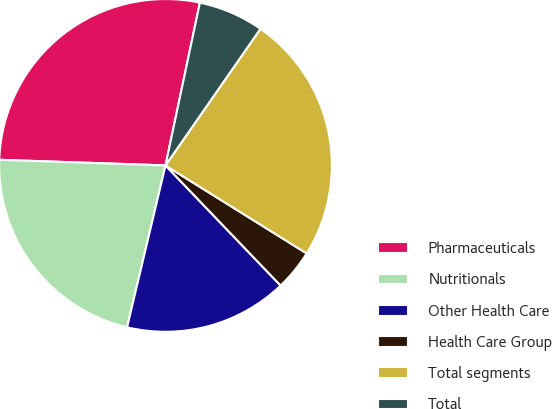Convert chart to OTSL. <chart><loc_0><loc_0><loc_500><loc_500><pie_chart><fcel>Pharmaceuticals<fcel>Nutritionals<fcel>Other Health Care<fcel>Health Care Group<fcel>Total segments<fcel>Total<nl><fcel>27.78%<fcel>21.83%<fcel>15.87%<fcel>3.97%<fcel>24.21%<fcel>6.35%<nl></chart> 